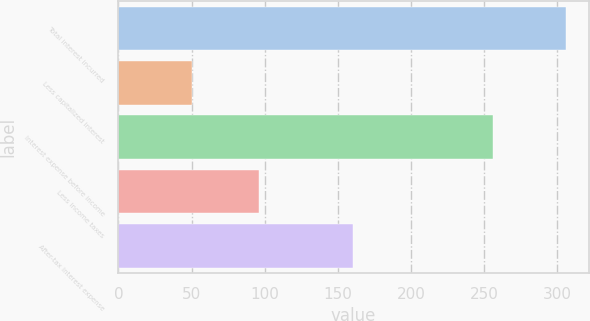Convert chart to OTSL. <chart><loc_0><loc_0><loc_500><loc_500><bar_chart><fcel>Total interest incurred<fcel>Less capitalized interest<fcel>Interest expense before income<fcel>Less income taxes<fcel>After-tax interest expense<nl><fcel>306<fcel>50<fcel>256<fcel>96<fcel>160<nl></chart> 